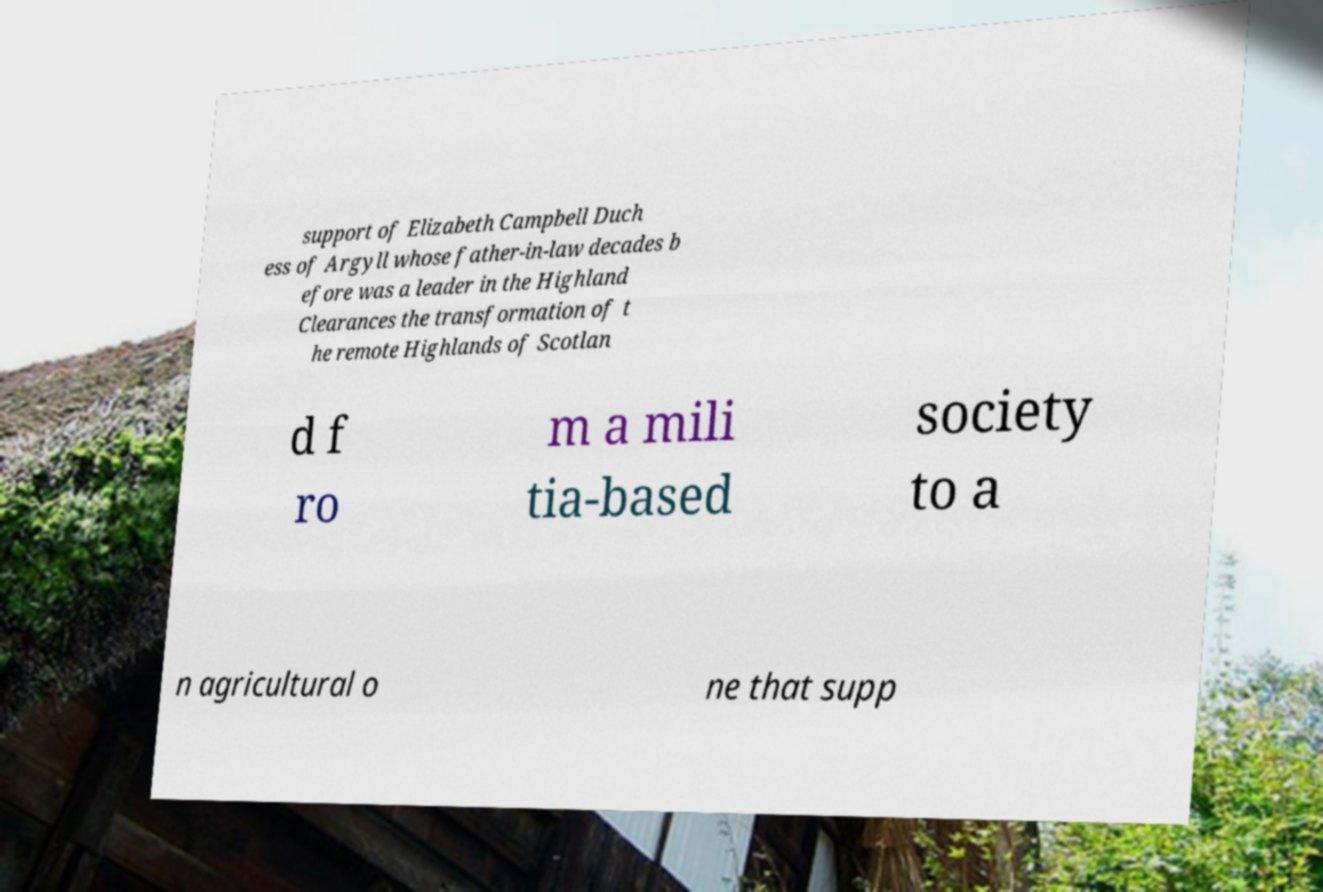Can you read and provide the text displayed in the image?This photo seems to have some interesting text. Can you extract and type it out for me? support of Elizabeth Campbell Duch ess of Argyll whose father-in-law decades b efore was a leader in the Highland Clearances the transformation of t he remote Highlands of Scotlan d f ro m a mili tia-based society to a n agricultural o ne that supp 